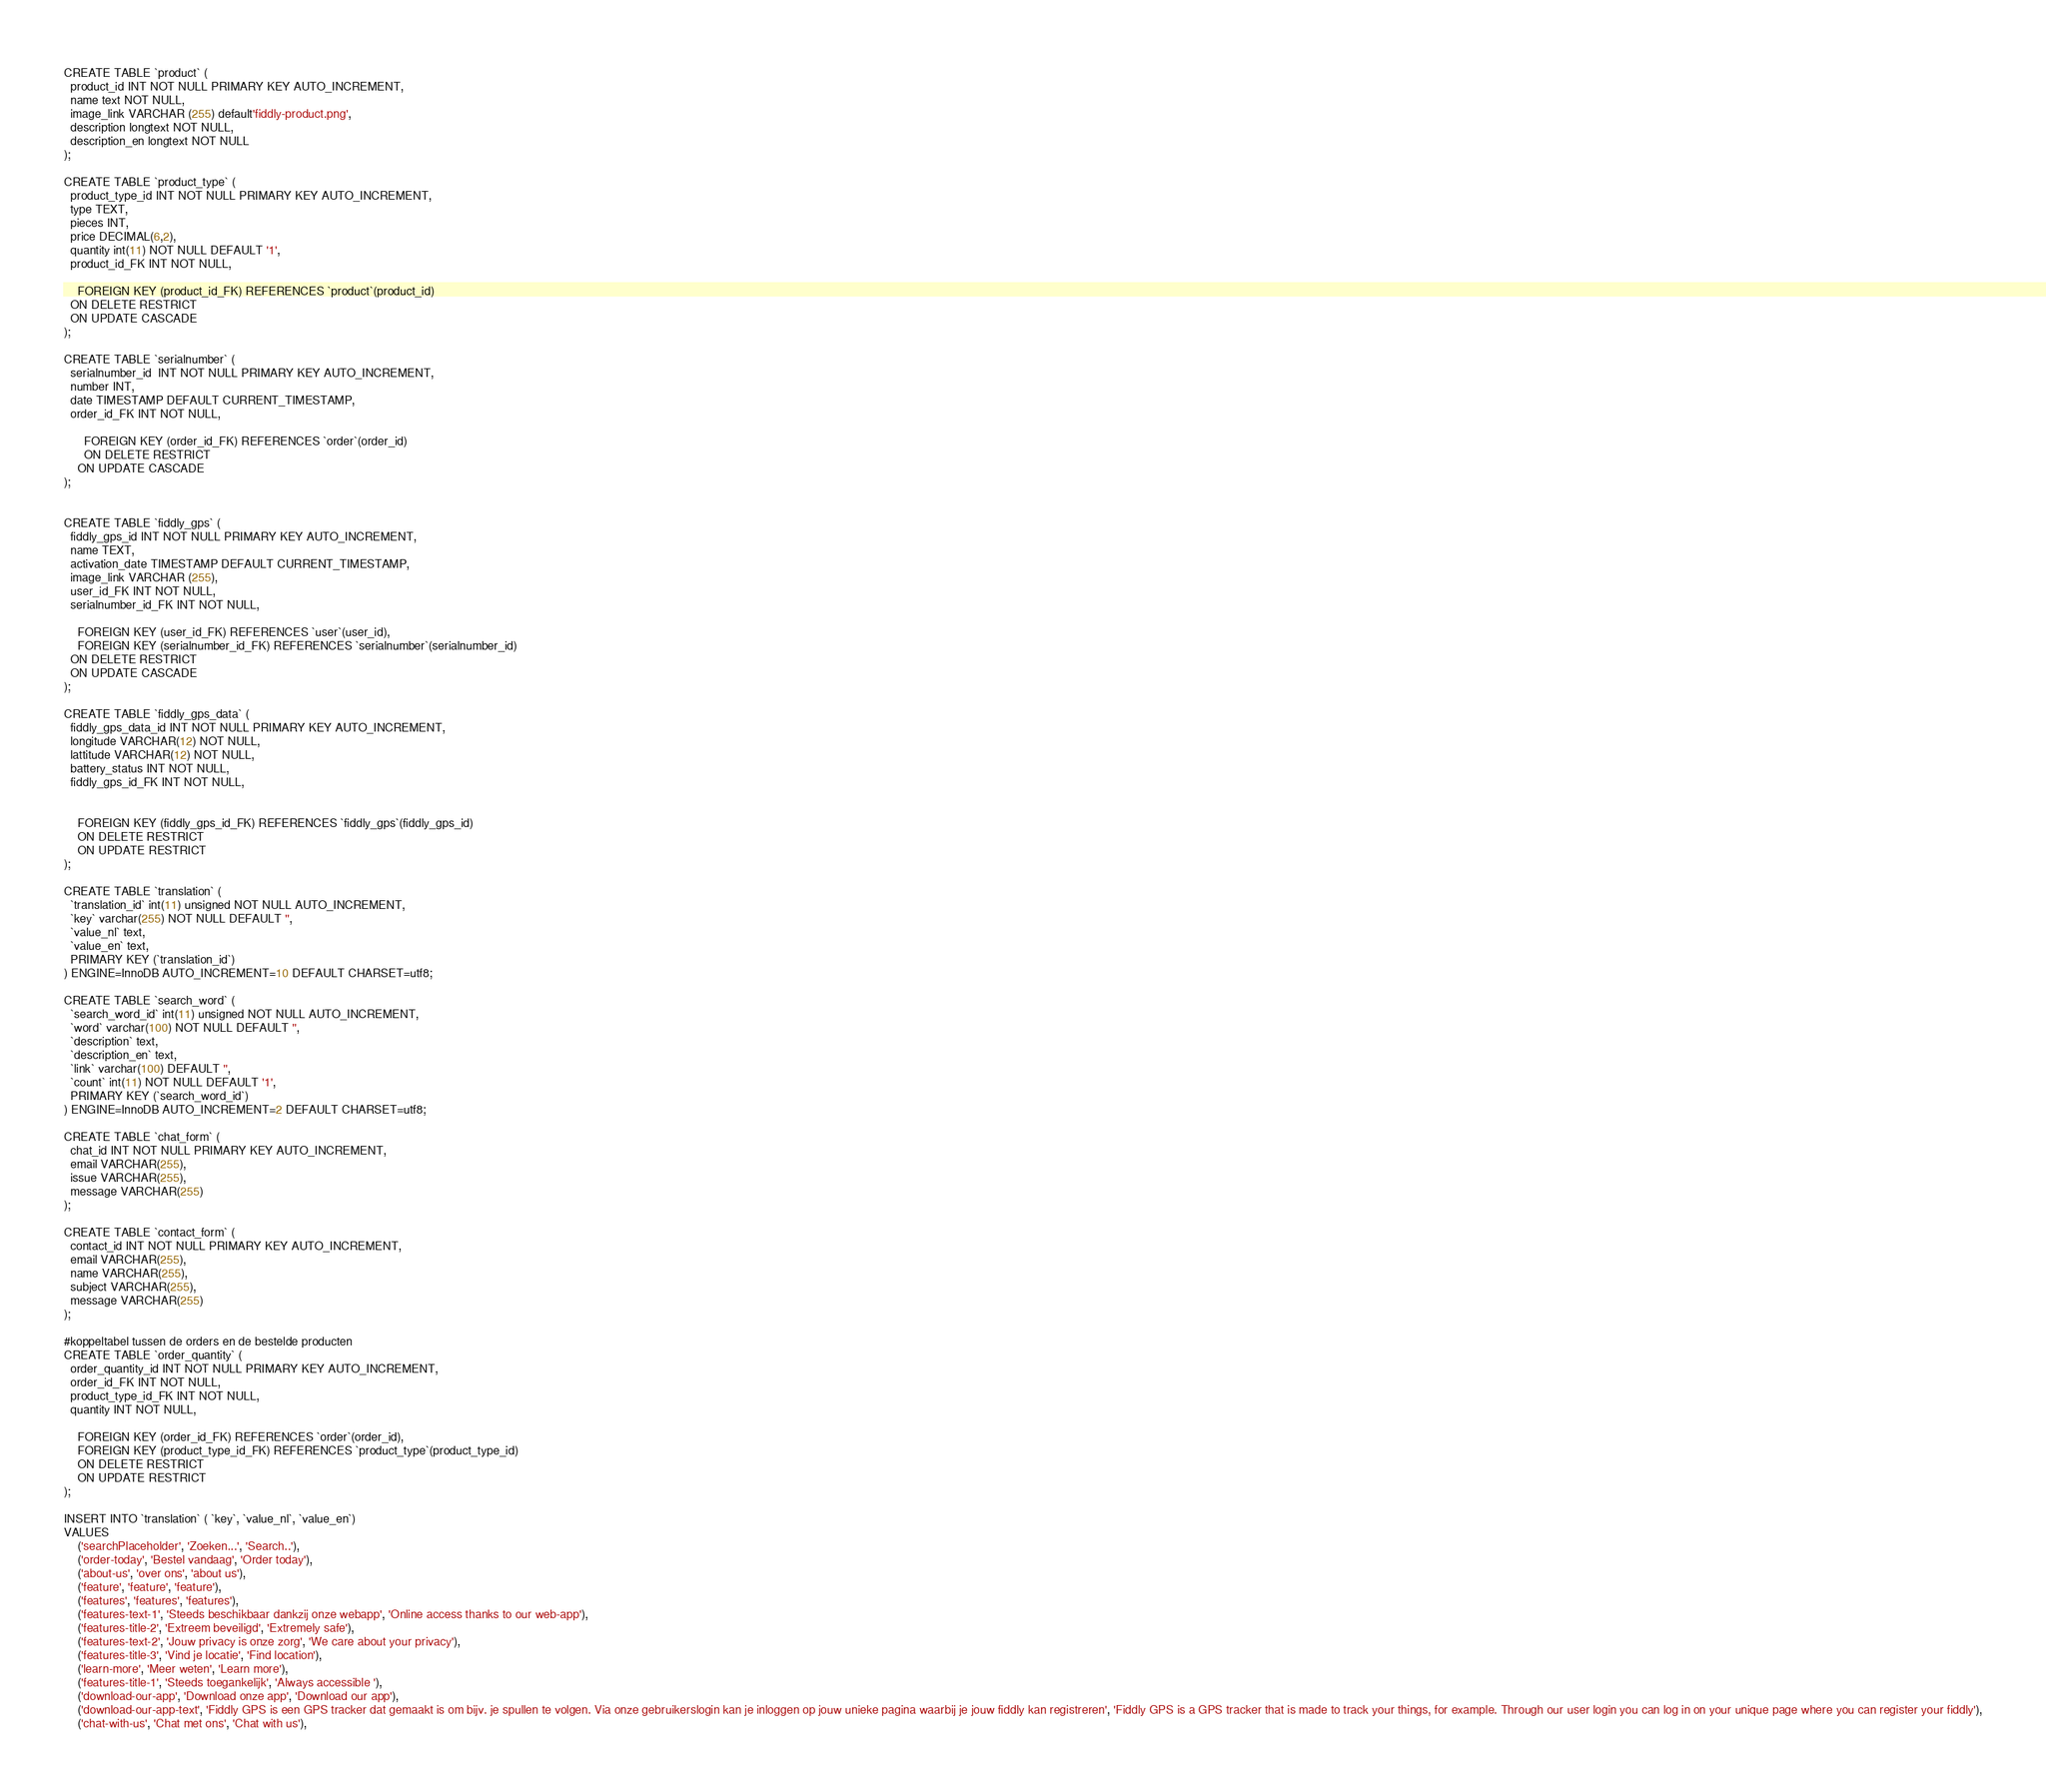<code> <loc_0><loc_0><loc_500><loc_500><_SQL_>

CREATE TABLE `product` (
  product_id INT NOT NULL PRIMARY KEY AUTO_INCREMENT,
  name text NOT NULL,
  image_link VARCHAR (255) default'fiddly-product.png',
  description longtext NOT NULL,
  description_en longtext NOT NULL
);

CREATE TABLE `product_type` (
  product_type_id INT NOT NULL PRIMARY KEY AUTO_INCREMENT,
  type TEXT,
  pieces INT,
  price DECIMAL(6,2),
  quantity int(11) NOT NULL DEFAULT '1',
  product_id_FK INT NOT NULL,

    FOREIGN KEY (product_id_FK) REFERENCES `product`(product_id)
  ON DELETE RESTRICT
  ON UPDATE CASCADE
);

CREATE TABLE `serialnumber` (
  serialnumber_id  INT NOT NULL PRIMARY KEY AUTO_INCREMENT,
  number INT,
  date TIMESTAMP DEFAULT CURRENT_TIMESTAMP,
  order_id_FK INT NOT NULL,

      FOREIGN KEY (order_id_FK) REFERENCES `order`(order_id)
      ON DELETE RESTRICT
    ON UPDATE CASCADE
);


CREATE TABLE `fiddly_gps` (
  fiddly_gps_id INT NOT NULL PRIMARY KEY AUTO_INCREMENT,
  name TEXT,
  activation_date TIMESTAMP DEFAULT CURRENT_TIMESTAMP,
  image_link VARCHAR (255),
  user_id_FK INT NOT NULL,
  serialnumber_id_FK INT NOT NULL,

    FOREIGN KEY (user_id_FK) REFERENCES `user`(user_id),
    FOREIGN KEY (serialnumber_id_FK) REFERENCES `serialnumber`(serialnumber_id)
  ON DELETE RESTRICT
  ON UPDATE CASCADE
);

CREATE TABLE `fiddly_gps_data` (
  fiddly_gps_data_id INT NOT NULL PRIMARY KEY AUTO_INCREMENT,
  longitude VARCHAR(12) NOT NULL,
  lattitude VARCHAR(12) NOT NULL,
  battery_status INT NOT NULL,
  fiddly_gps_id_FK INT NOT NULL,


    FOREIGN KEY (fiddly_gps_id_FK) REFERENCES `fiddly_gps`(fiddly_gps_id)
    ON DELETE RESTRICT
    ON UPDATE RESTRICT
);

CREATE TABLE `translation` (
  `translation_id` int(11) unsigned NOT NULL AUTO_INCREMENT,
  `key` varchar(255) NOT NULL DEFAULT '',
  `value_nl` text,
  `value_en` text,
  PRIMARY KEY (`translation_id`)
) ENGINE=InnoDB AUTO_INCREMENT=10 DEFAULT CHARSET=utf8;

CREATE TABLE `search_word` (
  `search_word_id` int(11) unsigned NOT NULL AUTO_INCREMENT,
  `word` varchar(100) NOT NULL DEFAULT '',
  `description` text,
  `description_en` text,
  `link` varchar(100) DEFAULT '',
  `count` int(11) NOT NULL DEFAULT '1',
  PRIMARY KEY (`search_word_id`)
) ENGINE=InnoDB AUTO_INCREMENT=2 DEFAULT CHARSET=utf8;

CREATE TABLE `chat_form` (
  chat_id INT NOT NULL PRIMARY KEY AUTO_INCREMENT,
  email VARCHAR(255),
  issue VARCHAR(255),
  message VARCHAR(255)
);

CREATE TABLE `contact_form` (
  contact_id INT NOT NULL PRIMARY KEY AUTO_INCREMENT,
  email VARCHAR(255),
  name VARCHAR(255),
  subject VARCHAR(255),
  message VARCHAR(255)
);

#koppeltabel tussen de orders en de bestelde producten
CREATE TABLE `order_quantity` (
  order_quantity_id INT NOT NULL PRIMARY KEY AUTO_INCREMENT,
  order_id_FK INT NOT NULL,
  product_type_id_FK INT NOT NULL,
  quantity INT NOT NULL,

    FOREIGN KEY (order_id_FK) REFERENCES `order`(order_id),
    FOREIGN KEY (product_type_id_FK) REFERENCES `product_type`(product_type_id)
    ON DELETE RESTRICT
    ON UPDATE RESTRICT
);

INSERT INTO `translation` ( `key`, `value_nl`, `value_en`)
VALUES
	('searchPlaceholder', 'Zoeken...', 'Search..'),
	('order-today', 'Bestel vandaag', 'Order today'),
	('about-us', 'over ons', 'about us'),
	('feature', 'feature', 'feature'),
	('features', 'features', 'features'),
	('features-text-1', 'Steeds beschikbaar dankzij onze webapp', 'Online access thanks to our web-app'),
	('features-title-2', 'Extreem beveiligd', 'Extremely safe'),
	('features-text-2', 'Jouw privacy is onze zorg', 'We care about your privacy'),
	('features-title-3', 'Vind je locatie', 'Find location'),
	('learn-more', 'Meer weten', 'Learn more'),
	('features-title-1', 'Steeds toegankelijk', 'Always accessible '),
	('download-our-app', 'Download onze app', 'Download our app'),
	('download-our-app-text', 'Fiddly GPS is een GPS tracker dat gemaakt is om bijv. je spullen te volgen. Via onze gebruikerslogin kan je inloggen op jouw unieke pagina waarbij je jouw fiddly kan registreren', 'Fiddly GPS is a GPS tracker that is made to track your things, for example. Through our user login you can log in on your unique page where you can register your fiddly'),
	('chat-with-us', 'Chat met ons', 'Chat with us'),</code> 